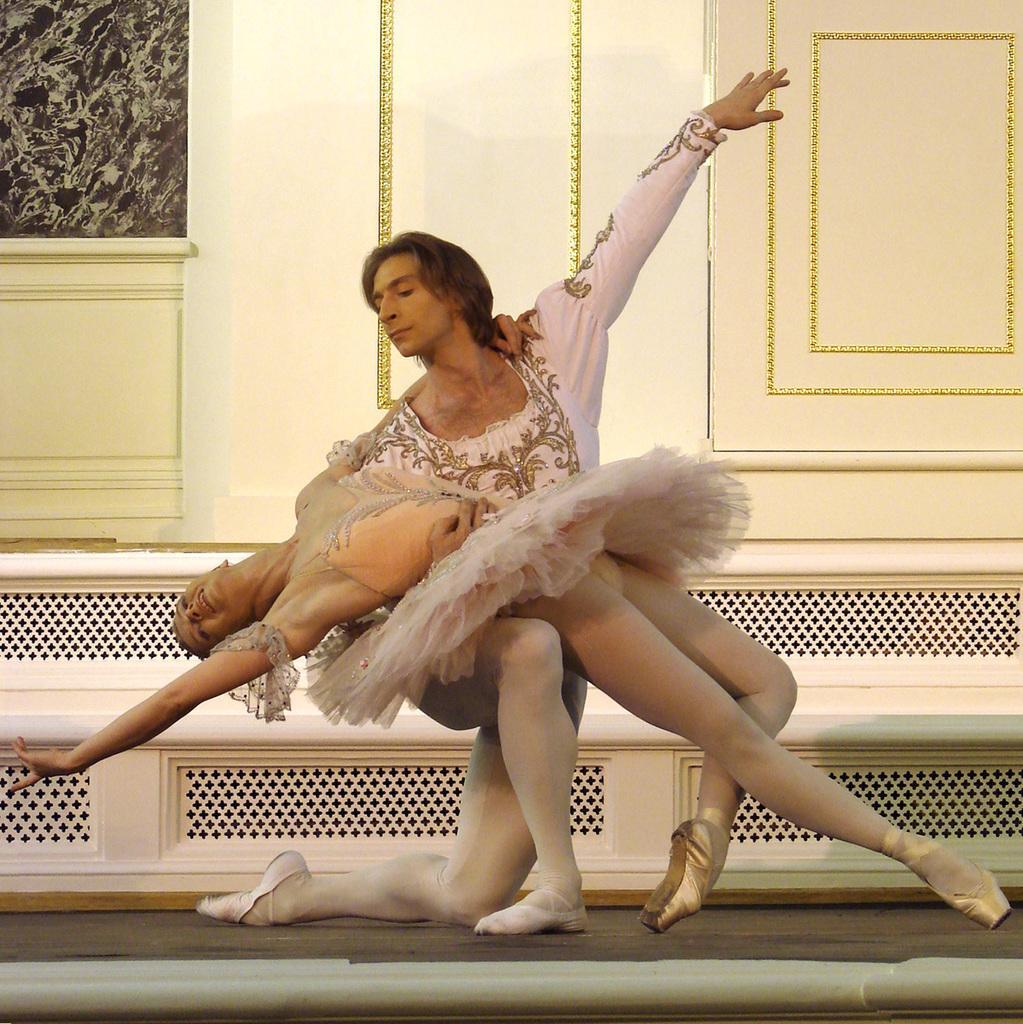Please provide a concise description of this image. In this picture we can see a man and a woman dancing and in the background we can see wall. 